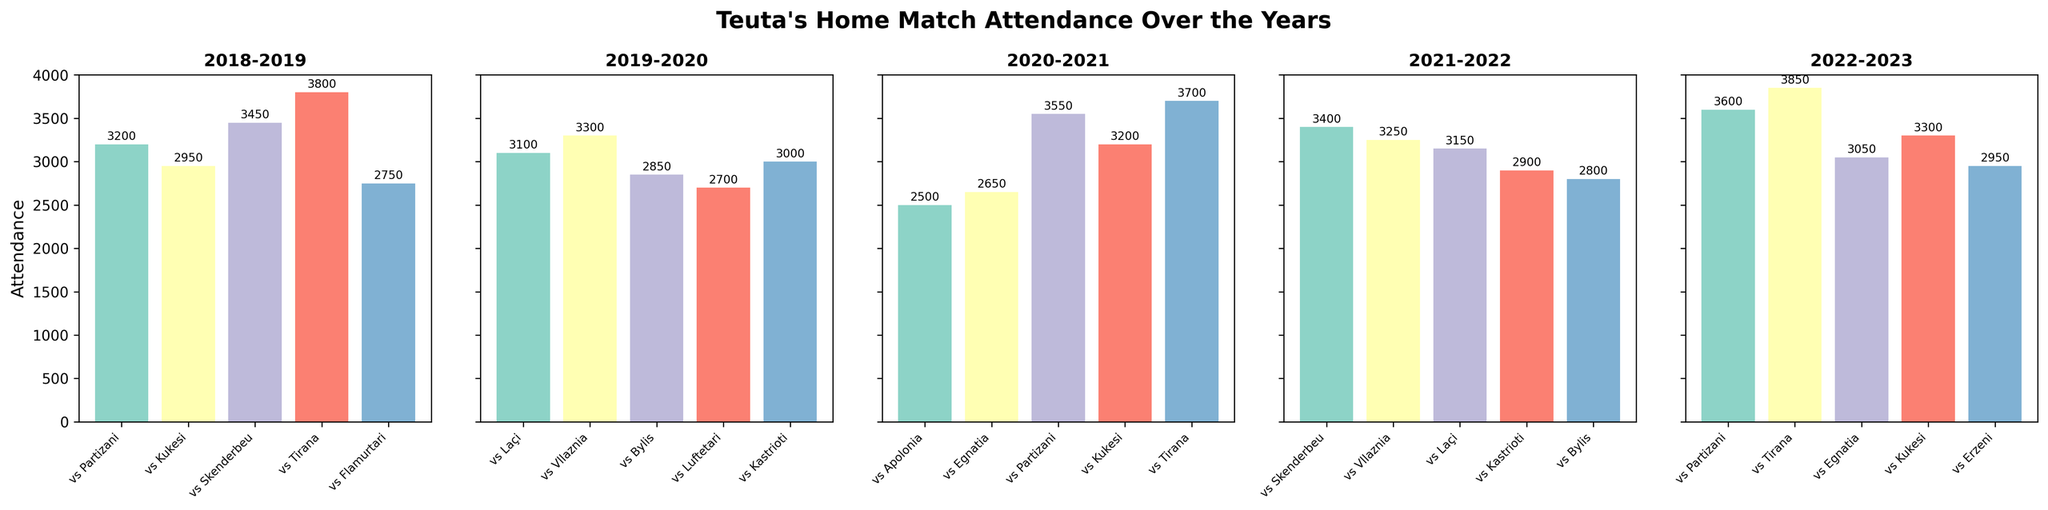Which match had the highest attendance in the 2018-2019 season? The highest attendance can be found by looking at the tallest bar in the 2018-2019 subplot. The bar labeled vs Tirana is the tallest, indicating the highest attendance.
Answer: vs Tirana What is the average attendance for Teuta's home matches in the 2021-2022 season? To calculate the average, add all attendance figures from the 2021-2022 season and divide by the number of matches. The values are: 3400, 3250, 3150, 2900, and 2800. The sum is 15500, and there are 5 matches, so the average is 15500 / 5.
Answer: 3100 In which season did the match against Partizani have the highest attendance? Identify the attendance figures for matches against Partizani in each season. Compare the figures: 3200 (2018-2019), 3550 (2020-2021), and 3600 (2022-2023). The highest is in the 2022-2023 season.
Answer: 2022-2023 Which match had the lowest attendance in the 2019-2020 season? The lowest attendance can be identified by finding the shortest bar in the 2019-2020 subplot. The bar labeled vs Luftetari is the shortest.
Answer: vs Luftetari Compare the attendance for matches against Tirana between the 2018-2019 and 2022-2023 seasons. Which season had higher attendance? Refer to the 2018-2019 and 2022-2023 subplots. For 2018-2019, the attendance is 3800. For 2022-2023, it is 3850. Comparing these, 2022-2023 had higher attendance.
Answer: 2022-2023 How many matches in the 2020-2021 season had an attendance above 3000? Count the number of bars in the 2020-2021 subplot that extend above the 3000 mark. The matches vs Partizani (3550), vs Kukesi (3200), and vs Tirana (3700) qualify. There are 3 such matches.
Answer: 3 What was the difference in attendance between the match vs Vllaznia in the 2019-2020 season and the match vs Vllaznia in the 2021-2022 season? Identify the attendance figures for both matches: 3300 (2019-2020) and 3250 (2021-2022). Compute the difference: 3300 - 3250.
Answer: 50 During which season did Teuta play the most home matches? Count the number of matches in each subplot. The 2022-2023 season has 5 matches, the 2021-2022 season has 5 matches, and so on. All seasons have 5 matches. So, there is no single season with the most matches.
Answer: All seasons What is the trend in attendance for matches against Kukesi over the five years? Note the attendance figures for matches against Kukesi: 2018-2019 (2950), 2020-2021 (3200), 2022-2023 (3300). The values show an increasing trend over the years.
Answer: Increasing 